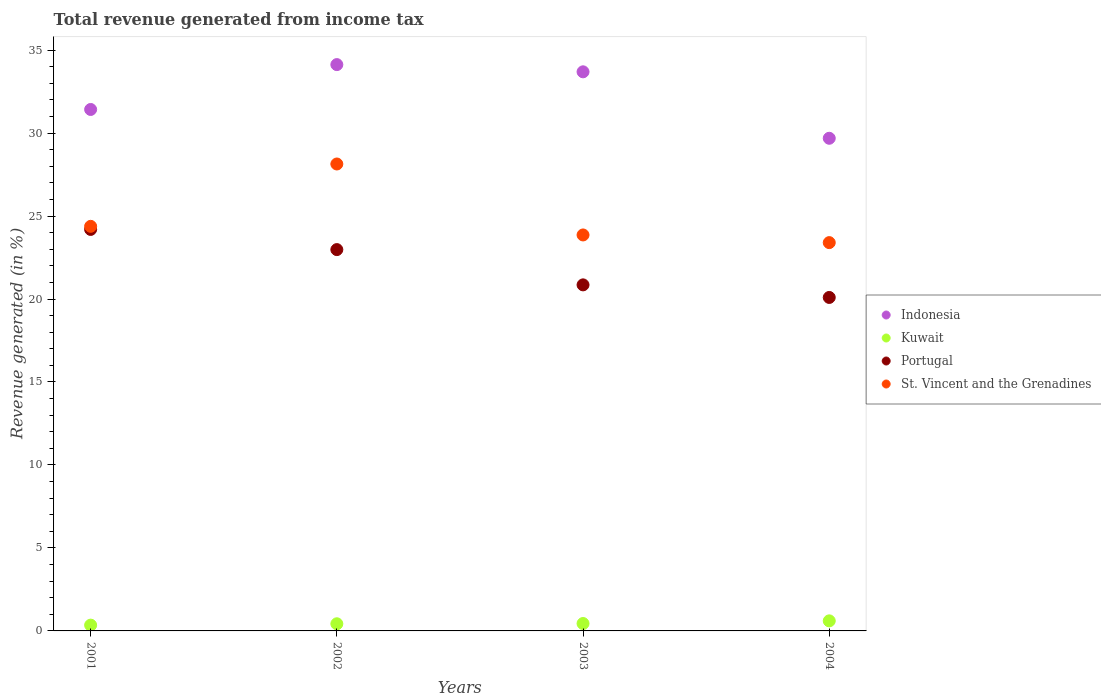How many different coloured dotlines are there?
Ensure brevity in your answer.  4. What is the total revenue generated in Kuwait in 2002?
Your answer should be very brief. 0.43. Across all years, what is the maximum total revenue generated in Portugal?
Your answer should be very brief. 24.19. Across all years, what is the minimum total revenue generated in St. Vincent and the Grenadines?
Your answer should be compact. 23.4. In which year was the total revenue generated in Indonesia minimum?
Keep it short and to the point. 2004. What is the total total revenue generated in Indonesia in the graph?
Ensure brevity in your answer.  128.93. What is the difference between the total revenue generated in St. Vincent and the Grenadines in 2001 and that in 2003?
Your answer should be very brief. 0.52. What is the difference between the total revenue generated in Portugal in 2003 and the total revenue generated in Indonesia in 2001?
Make the answer very short. -10.57. What is the average total revenue generated in St. Vincent and the Grenadines per year?
Your answer should be very brief. 24.94. In the year 2002, what is the difference between the total revenue generated in Portugal and total revenue generated in Kuwait?
Provide a succinct answer. 22.55. What is the ratio of the total revenue generated in Kuwait in 2003 to that in 2004?
Provide a succinct answer. 0.74. Is the difference between the total revenue generated in Portugal in 2002 and 2004 greater than the difference between the total revenue generated in Kuwait in 2002 and 2004?
Offer a terse response. Yes. What is the difference between the highest and the second highest total revenue generated in Indonesia?
Offer a terse response. 0.43. What is the difference between the highest and the lowest total revenue generated in St. Vincent and the Grenadines?
Your response must be concise. 4.74. Is it the case that in every year, the sum of the total revenue generated in St. Vincent and the Grenadines and total revenue generated in Indonesia  is greater than the total revenue generated in Kuwait?
Your response must be concise. Yes. Is the total revenue generated in Kuwait strictly less than the total revenue generated in Indonesia over the years?
Make the answer very short. Yes. How many dotlines are there?
Your answer should be compact. 4. What is the difference between two consecutive major ticks on the Y-axis?
Make the answer very short. 5. Does the graph contain any zero values?
Your answer should be very brief. No. Where does the legend appear in the graph?
Your response must be concise. Center right. How many legend labels are there?
Make the answer very short. 4. What is the title of the graph?
Keep it short and to the point. Total revenue generated from income tax. What is the label or title of the Y-axis?
Keep it short and to the point. Revenue generated (in %). What is the Revenue generated (in %) of Indonesia in 2001?
Your answer should be very brief. 31.42. What is the Revenue generated (in %) in Kuwait in 2001?
Your response must be concise. 0.35. What is the Revenue generated (in %) of Portugal in 2001?
Give a very brief answer. 24.19. What is the Revenue generated (in %) in St. Vincent and the Grenadines in 2001?
Give a very brief answer. 24.38. What is the Revenue generated (in %) of Indonesia in 2002?
Your answer should be very brief. 34.13. What is the Revenue generated (in %) of Kuwait in 2002?
Offer a terse response. 0.43. What is the Revenue generated (in %) in Portugal in 2002?
Offer a terse response. 22.98. What is the Revenue generated (in %) of St. Vincent and the Grenadines in 2002?
Make the answer very short. 28.14. What is the Revenue generated (in %) of Indonesia in 2003?
Keep it short and to the point. 33.69. What is the Revenue generated (in %) in Kuwait in 2003?
Keep it short and to the point. 0.45. What is the Revenue generated (in %) in Portugal in 2003?
Offer a very short reply. 20.85. What is the Revenue generated (in %) in St. Vincent and the Grenadines in 2003?
Provide a short and direct response. 23.86. What is the Revenue generated (in %) in Indonesia in 2004?
Your answer should be compact. 29.69. What is the Revenue generated (in %) in Kuwait in 2004?
Offer a very short reply. 0.61. What is the Revenue generated (in %) of Portugal in 2004?
Your answer should be compact. 20.09. What is the Revenue generated (in %) in St. Vincent and the Grenadines in 2004?
Make the answer very short. 23.4. Across all years, what is the maximum Revenue generated (in %) of Indonesia?
Your answer should be compact. 34.13. Across all years, what is the maximum Revenue generated (in %) of Kuwait?
Make the answer very short. 0.61. Across all years, what is the maximum Revenue generated (in %) of Portugal?
Your answer should be compact. 24.19. Across all years, what is the maximum Revenue generated (in %) in St. Vincent and the Grenadines?
Provide a succinct answer. 28.14. Across all years, what is the minimum Revenue generated (in %) of Indonesia?
Offer a very short reply. 29.69. Across all years, what is the minimum Revenue generated (in %) in Kuwait?
Offer a very short reply. 0.35. Across all years, what is the minimum Revenue generated (in %) in Portugal?
Provide a short and direct response. 20.09. Across all years, what is the minimum Revenue generated (in %) in St. Vincent and the Grenadines?
Provide a short and direct response. 23.4. What is the total Revenue generated (in %) in Indonesia in the graph?
Give a very brief answer. 128.93. What is the total Revenue generated (in %) of Kuwait in the graph?
Your answer should be very brief. 1.83. What is the total Revenue generated (in %) in Portugal in the graph?
Keep it short and to the point. 88.12. What is the total Revenue generated (in %) in St. Vincent and the Grenadines in the graph?
Your response must be concise. 99.78. What is the difference between the Revenue generated (in %) in Indonesia in 2001 and that in 2002?
Your response must be concise. -2.7. What is the difference between the Revenue generated (in %) of Kuwait in 2001 and that in 2002?
Give a very brief answer. -0.08. What is the difference between the Revenue generated (in %) in Portugal in 2001 and that in 2002?
Give a very brief answer. 1.22. What is the difference between the Revenue generated (in %) of St. Vincent and the Grenadines in 2001 and that in 2002?
Ensure brevity in your answer.  -3.76. What is the difference between the Revenue generated (in %) of Indonesia in 2001 and that in 2003?
Keep it short and to the point. -2.27. What is the difference between the Revenue generated (in %) of Kuwait in 2001 and that in 2003?
Your answer should be very brief. -0.1. What is the difference between the Revenue generated (in %) of Portugal in 2001 and that in 2003?
Provide a succinct answer. 3.34. What is the difference between the Revenue generated (in %) of St. Vincent and the Grenadines in 2001 and that in 2003?
Keep it short and to the point. 0.52. What is the difference between the Revenue generated (in %) in Indonesia in 2001 and that in 2004?
Offer a terse response. 1.74. What is the difference between the Revenue generated (in %) of Kuwait in 2001 and that in 2004?
Your response must be concise. -0.26. What is the difference between the Revenue generated (in %) of Portugal in 2001 and that in 2004?
Provide a short and direct response. 4.1. What is the difference between the Revenue generated (in %) in St. Vincent and the Grenadines in 2001 and that in 2004?
Give a very brief answer. 0.98. What is the difference between the Revenue generated (in %) of Indonesia in 2002 and that in 2003?
Your answer should be very brief. 0.43. What is the difference between the Revenue generated (in %) in Kuwait in 2002 and that in 2003?
Offer a very short reply. -0.02. What is the difference between the Revenue generated (in %) of Portugal in 2002 and that in 2003?
Offer a very short reply. 2.13. What is the difference between the Revenue generated (in %) in St. Vincent and the Grenadines in 2002 and that in 2003?
Provide a succinct answer. 4.28. What is the difference between the Revenue generated (in %) in Indonesia in 2002 and that in 2004?
Offer a very short reply. 4.44. What is the difference between the Revenue generated (in %) in Kuwait in 2002 and that in 2004?
Your answer should be compact. -0.18. What is the difference between the Revenue generated (in %) of Portugal in 2002 and that in 2004?
Offer a terse response. 2.88. What is the difference between the Revenue generated (in %) of St. Vincent and the Grenadines in 2002 and that in 2004?
Make the answer very short. 4.74. What is the difference between the Revenue generated (in %) of Indonesia in 2003 and that in 2004?
Keep it short and to the point. 4. What is the difference between the Revenue generated (in %) in Kuwait in 2003 and that in 2004?
Offer a very short reply. -0.16. What is the difference between the Revenue generated (in %) in Portugal in 2003 and that in 2004?
Your answer should be very brief. 0.76. What is the difference between the Revenue generated (in %) of St. Vincent and the Grenadines in 2003 and that in 2004?
Your answer should be compact. 0.46. What is the difference between the Revenue generated (in %) in Indonesia in 2001 and the Revenue generated (in %) in Kuwait in 2002?
Offer a terse response. 30.99. What is the difference between the Revenue generated (in %) of Indonesia in 2001 and the Revenue generated (in %) of Portugal in 2002?
Your response must be concise. 8.44. What is the difference between the Revenue generated (in %) of Indonesia in 2001 and the Revenue generated (in %) of St. Vincent and the Grenadines in 2002?
Your response must be concise. 3.29. What is the difference between the Revenue generated (in %) of Kuwait in 2001 and the Revenue generated (in %) of Portugal in 2002?
Provide a succinct answer. -22.63. What is the difference between the Revenue generated (in %) in Kuwait in 2001 and the Revenue generated (in %) in St. Vincent and the Grenadines in 2002?
Give a very brief answer. -27.79. What is the difference between the Revenue generated (in %) of Portugal in 2001 and the Revenue generated (in %) of St. Vincent and the Grenadines in 2002?
Provide a short and direct response. -3.94. What is the difference between the Revenue generated (in %) in Indonesia in 2001 and the Revenue generated (in %) in Kuwait in 2003?
Make the answer very short. 30.98. What is the difference between the Revenue generated (in %) in Indonesia in 2001 and the Revenue generated (in %) in Portugal in 2003?
Your answer should be compact. 10.57. What is the difference between the Revenue generated (in %) in Indonesia in 2001 and the Revenue generated (in %) in St. Vincent and the Grenadines in 2003?
Offer a very short reply. 7.56. What is the difference between the Revenue generated (in %) of Kuwait in 2001 and the Revenue generated (in %) of Portugal in 2003?
Offer a terse response. -20.5. What is the difference between the Revenue generated (in %) in Kuwait in 2001 and the Revenue generated (in %) in St. Vincent and the Grenadines in 2003?
Offer a very short reply. -23.51. What is the difference between the Revenue generated (in %) in Portugal in 2001 and the Revenue generated (in %) in St. Vincent and the Grenadines in 2003?
Give a very brief answer. 0.33. What is the difference between the Revenue generated (in %) of Indonesia in 2001 and the Revenue generated (in %) of Kuwait in 2004?
Ensure brevity in your answer.  30.82. What is the difference between the Revenue generated (in %) in Indonesia in 2001 and the Revenue generated (in %) in Portugal in 2004?
Your answer should be compact. 11.33. What is the difference between the Revenue generated (in %) of Indonesia in 2001 and the Revenue generated (in %) of St. Vincent and the Grenadines in 2004?
Offer a terse response. 8.02. What is the difference between the Revenue generated (in %) in Kuwait in 2001 and the Revenue generated (in %) in Portugal in 2004?
Your response must be concise. -19.75. What is the difference between the Revenue generated (in %) of Kuwait in 2001 and the Revenue generated (in %) of St. Vincent and the Grenadines in 2004?
Offer a terse response. -23.05. What is the difference between the Revenue generated (in %) in Portugal in 2001 and the Revenue generated (in %) in St. Vincent and the Grenadines in 2004?
Your response must be concise. 0.79. What is the difference between the Revenue generated (in %) of Indonesia in 2002 and the Revenue generated (in %) of Kuwait in 2003?
Make the answer very short. 33.68. What is the difference between the Revenue generated (in %) of Indonesia in 2002 and the Revenue generated (in %) of Portugal in 2003?
Ensure brevity in your answer.  13.27. What is the difference between the Revenue generated (in %) in Indonesia in 2002 and the Revenue generated (in %) in St. Vincent and the Grenadines in 2003?
Offer a terse response. 10.27. What is the difference between the Revenue generated (in %) of Kuwait in 2002 and the Revenue generated (in %) of Portugal in 2003?
Provide a short and direct response. -20.42. What is the difference between the Revenue generated (in %) of Kuwait in 2002 and the Revenue generated (in %) of St. Vincent and the Grenadines in 2003?
Your answer should be compact. -23.43. What is the difference between the Revenue generated (in %) in Portugal in 2002 and the Revenue generated (in %) in St. Vincent and the Grenadines in 2003?
Provide a succinct answer. -0.88. What is the difference between the Revenue generated (in %) of Indonesia in 2002 and the Revenue generated (in %) of Kuwait in 2004?
Provide a short and direct response. 33.52. What is the difference between the Revenue generated (in %) of Indonesia in 2002 and the Revenue generated (in %) of Portugal in 2004?
Offer a very short reply. 14.03. What is the difference between the Revenue generated (in %) of Indonesia in 2002 and the Revenue generated (in %) of St. Vincent and the Grenadines in 2004?
Provide a short and direct response. 10.73. What is the difference between the Revenue generated (in %) of Kuwait in 2002 and the Revenue generated (in %) of Portugal in 2004?
Give a very brief answer. -19.66. What is the difference between the Revenue generated (in %) in Kuwait in 2002 and the Revenue generated (in %) in St. Vincent and the Grenadines in 2004?
Provide a short and direct response. -22.97. What is the difference between the Revenue generated (in %) of Portugal in 2002 and the Revenue generated (in %) of St. Vincent and the Grenadines in 2004?
Your answer should be compact. -0.42. What is the difference between the Revenue generated (in %) of Indonesia in 2003 and the Revenue generated (in %) of Kuwait in 2004?
Give a very brief answer. 33.09. What is the difference between the Revenue generated (in %) of Indonesia in 2003 and the Revenue generated (in %) of Portugal in 2004?
Your answer should be compact. 13.6. What is the difference between the Revenue generated (in %) in Indonesia in 2003 and the Revenue generated (in %) in St. Vincent and the Grenadines in 2004?
Provide a succinct answer. 10.29. What is the difference between the Revenue generated (in %) in Kuwait in 2003 and the Revenue generated (in %) in Portugal in 2004?
Your response must be concise. -19.65. What is the difference between the Revenue generated (in %) in Kuwait in 2003 and the Revenue generated (in %) in St. Vincent and the Grenadines in 2004?
Your answer should be very brief. -22.95. What is the difference between the Revenue generated (in %) in Portugal in 2003 and the Revenue generated (in %) in St. Vincent and the Grenadines in 2004?
Give a very brief answer. -2.55. What is the average Revenue generated (in %) of Indonesia per year?
Provide a short and direct response. 32.23. What is the average Revenue generated (in %) in Kuwait per year?
Provide a succinct answer. 0.46. What is the average Revenue generated (in %) in Portugal per year?
Keep it short and to the point. 22.03. What is the average Revenue generated (in %) of St. Vincent and the Grenadines per year?
Ensure brevity in your answer.  24.94. In the year 2001, what is the difference between the Revenue generated (in %) of Indonesia and Revenue generated (in %) of Kuwait?
Keep it short and to the point. 31.07. In the year 2001, what is the difference between the Revenue generated (in %) of Indonesia and Revenue generated (in %) of Portugal?
Your answer should be very brief. 7.23. In the year 2001, what is the difference between the Revenue generated (in %) of Indonesia and Revenue generated (in %) of St. Vincent and the Grenadines?
Offer a terse response. 7.04. In the year 2001, what is the difference between the Revenue generated (in %) in Kuwait and Revenue generated (in %) in Portugal?
Your answer should be compact. -23.84. In the year 2001, what is the difference between the Revenue generated (in %) of Kuwait and Revenue generated (in %) of St. Vincent and the Grenadines?
Keep it short and to the point. -24.03. In the year 2001, what is the difference between the Revenue generated (in %) in Portugal and Revenue generated (in %) in St. Vincent and the Grenadines?
Your answer should be very brief. -0.19. In the year 2002, what is the difference between the Revenue generated (in %) of Indonesia and Revenue generated (in %) of Kuwait?
Your response must be concise. 33.7. In the year 2002, what is the difference between the Revenue generated (in %) of Indonesia and Revenue generated (in %) of Portugal?
Offer a very short reply. 11.15. In the year 2002, what is the difference between the Revenue generated (in %) in Indonesia and Revenue generated (in %) in St. Vincent and the Grenadines?
Your answer should be compact. 5.99. In the year 2002, what is the difference between the Revenue generated (in %) in Kuwait and Revenue generated (in %) in Portugal?
Make the answer very short. -22.55. In the year 2002, what is the difference between the Revenue generated (in %) in Kuwait and Revenue generated (in %) in St. Vincent and the Grenadines?
Your answer should be very brief. -27.71. In the year 2002, what is the difference between the Revenue generated (in %) in Portugal and Revenue generated (in %) in St. Vincent and the Grenadines?
Offer a very short reply. -5.16. In the year 2003, what is the difference between the Revenue generated (in %) in Indonesia and Revenue generated (in %) in Kuwait?
Keep it short and to the point. 33.25. In the year 2003, what is the difference between the Revenue generated (in %) of Indonesia and Revenue generated (in %) of Portugal?
Provide a succinct answer. 12.84. In the year 2003, what is the difference between the Revenue generated (in %) in Indonesia and Revenue generated (in %) in St. Vincent and the Grenadines?
Offer a very short reply. 9.83. In the year 2003, what is the difference between the Revenue generated (in %) of Kuwait and Revenue generated (in %) of Portugal?
Provide a short and direct response. -20.41. In the year 2003, what is the difference between the Revenue generated (in %) of Kuwait and Revenue generated (in %) of St. Vincent and the Grenadines?
Offer a terse response. -23.41. In the year 2003, what is the difference between the Revenue generated (in %) of Portugal and Revenue generated (in %) of St. Vincent and the Grenadines?
Offer a terse response. -3.01. In the year 2004, what is the difference between the Revenue generated (in %) in Indonesia and Revenue generated (in %) in Kuwait?
Ensure brevity in your answer.  29.08. In the year 2004, what is the difference between the Revenue generated (in %) in Indonesia and Revenue generated (in %) in Portugal?
Offer a terse response. 9.59. In the year 2004, what is the difference between the Revenue generated (in %) in Indonesia and Revenue generated (in %) in St. Vincent and the Grenadines?
Provide a succinct answer. 6.29. In the year 2004, what is the difference between the Revenue generated (in %) of Kuwait and Revenue generated (in %) of Portugal?
Make the answer very short. -19.49. In the year 2004, what is the difference between the Revenue generated (in %) of Kuwait and Revenue generated (in %) of St. Vincent and the Grenadines?
Ensure brevity in your answer.  -22.79. In the year 2004, what is the difference between the Revenue generated (in %) of Portugal and Revenue generated (in %) of St. Vincent and the Grenadines?
Keep it short and to the point. -3.3. What is the ratio of the Revenue generated (in %) in Indonesia in 2001 to that in 2002?
Ensure brevity in your answer.  0.92. What is the ratio of the Revenue generated (in %) of Kuwait in 2001 to that in 2002?
Make the answer very short. 0.81. What is the ratio of the Revenue generated (in %) of Portugal in 2001 to that in 2002?
Provide a succinct answer. 1.05. What is the ratio of the Revenue generated (in %) in St. Vincent and the Grenadines in 2001 to that in 2002?
Your response must be concise. 0.87. What is the ratio of the Revenue generated (in %) of Indonesia in 2001 to that in 2003?
Ensure brevity in your answer.  0.93. What is the ratio of the Revenue generated (in %) of Kuwait in 2001 to that in 2003?
Make the answer very short. 0.78. What is the ratio of the Revenue generated (in %) of Portugal in 2001 to that in 2003?
Provide a short and direct response. 1.16. What is the ratio of the Revenue generated (in %) in St. Vincent and the Grenadines in 2001 to that in 2003?
Provide a succinct answer. 1.02. What is the ratio of the Revenue generated (in %) in Indonesia in 2001 to that in 2004?
Provide a short and direct response. 1.06. What is the ratio of the Revenue generated (in %) in Kuwait in 2001 to that in 2004?
Your answer should be very brief. 0.57. What is the ratio of the Revenue generated (in %) of Portugal in 2001 to that in 2004?
Offer a terse response. 1.2. What is the ratio of the Revenue generated (in %) in St. Vincent and the Grenadines in 2001 to that in 2004?
Make the answer very short. 1.04. What is the ratio of the Revenue generated (in %) of Indonesia in 2002 to that in 2003?
Your answer should be very brief. 1.01. What is the ratio of the Revenue generated (in %) in Kuwait in 2002 to that in 2003?
Make the answer very short. 0.96. What is the ratio of the Revenue generated (in %) in Portugal in 2002 to that in 2003?
Your response must be concise. 1.1. What is the ratio of the Revenue generated (in %) of St. Vincent and the Grenadines in 2002 to that in 2003?
Give a very brief answer. 1.18. What is the ratio of the Revenue generated (in %) of Indonesia in 2002 to that in 2004?
Your answer should be compact. 1.15. What is the ratio of the Revenue generated (in %) in Kuwait in 2002 to that in 2004?
Your answer should be compact. 0.71. What is the ratio of the Revenue generated (in %) of Portugal in 2002 to that in 2004?
Your answer should be compact. 1.14. What is the ratio of the Revenue generated (in %) in St. Vincent and the Grenadines in 2002 to that in 2004?
Provide a short and direct response. 1.2. What is the ratio of the Revenue generated (in %) of Indonesia in 2003 to that in 2004?
Provide a short and direct response. 1.13. What is the ratio of the Revenue generated (in %) in Kuwait in 2003 to that in 2004?
Keep it short and to the point. 0.74. What is the ratio of the Revenue generated (in %) in Portugal in 2003 to that in 2004?
Your answer should be compact. 1.04. What is the ratio of the Revenue generated (in %) in St. Vincent and the Grenadines in 2003 to that in 2004?
Provide a succinct answer. 1.02. What is the difference between the highest and the second highest Revenue generated (in %) in Indonesia?
Provide a short and direct response. 0.43. What is the difference between the highest and the second highest Revenue generated (in %) of Kuwait?
Ensure brevity in your answer.  0.16. What is the difference between the highest and the second highest Revenue generated (in %) in Portugal?
Your answer should be very brief. 1.22. What is the difference between the highest and the second highest Revenue generated (in %) in St. Vincent and the Grenadines?
Ensure brevity in your answer.  3.76. What is the difference between the highest and the lowest Revenue generated (in %) in Indonesia?
Your response must be concise. 4.44. What is the difference between the highest and the lowest Revenue generated (in %) in Kuwait?
Your answer should be compact. 0.26. What is the difference between the highest and the lowest Revenue generated (in %) of Portugal?
Ensure brevity in your answer.  4.1. What is the difference between the highest and the lowest Revenue generated (in %) in St. Vincent and the Grenadines?
Keep it short and to the point. 4.74. 